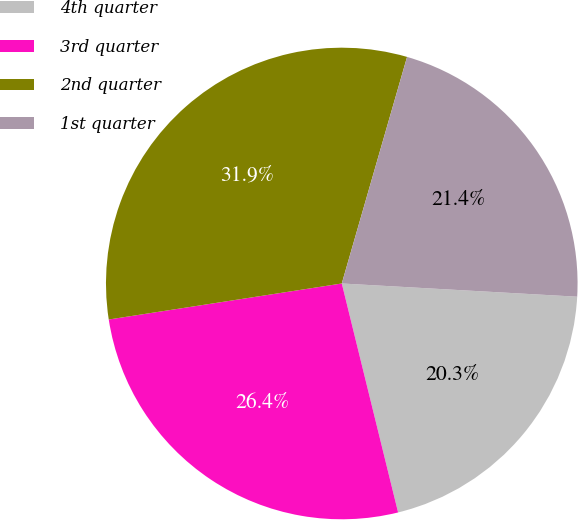Convert chart to OTSL. <chart><loc_0><loc_0><loc_500><loc_500><pie_chart><fcel>4th quarter<fcel>3rd quarter<fcel>2nd quarter<fcel>1st quarter<nl><fcel>20.27%<fcel>26.4%<fcel>31.91%<fcel>21.43%<nl></chart> 